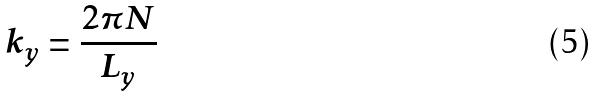Convert formula to latex. <formula><loc_0><loc_0><loc_500><loc_500>k _ { y } = \frac { 2 \pi N } { L _ { y } }</formula> 